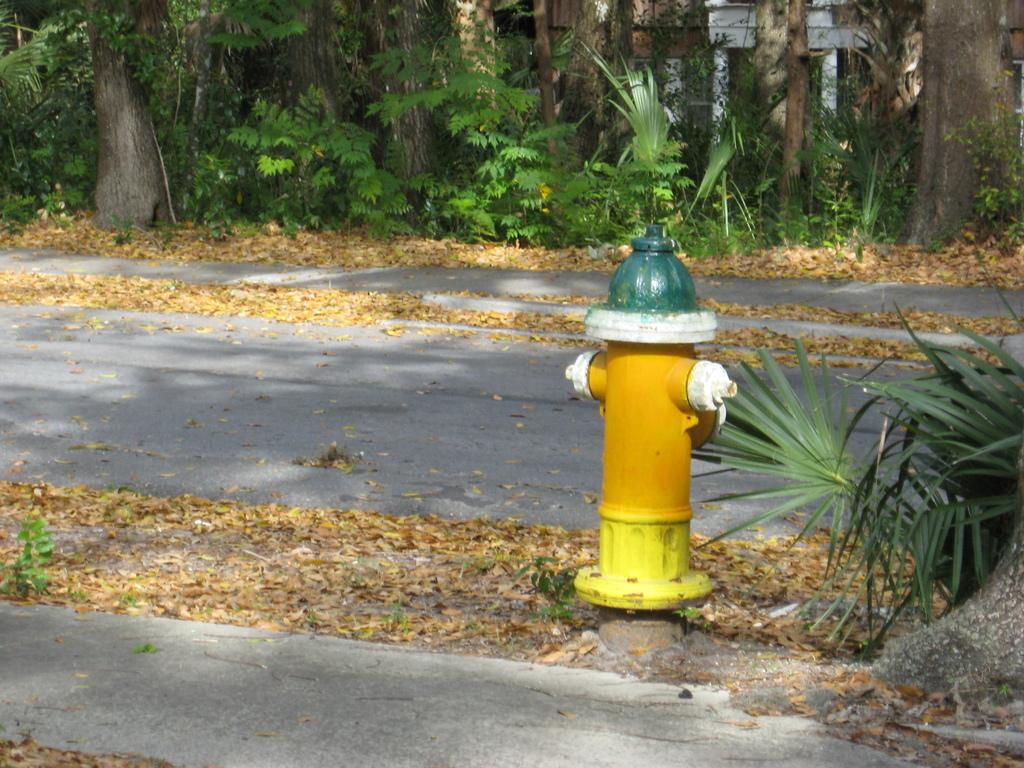What is the main object in the front of the image? There is a water hydrant in the front of the image. What can be found at the bottom of the image? There are leaves at the bottom of the image. What is visible in the background of the image? There are trees and plants in the background of the image. What type of blade can be seen cutting the beef in the image? There is no blade or beef present in the image. 